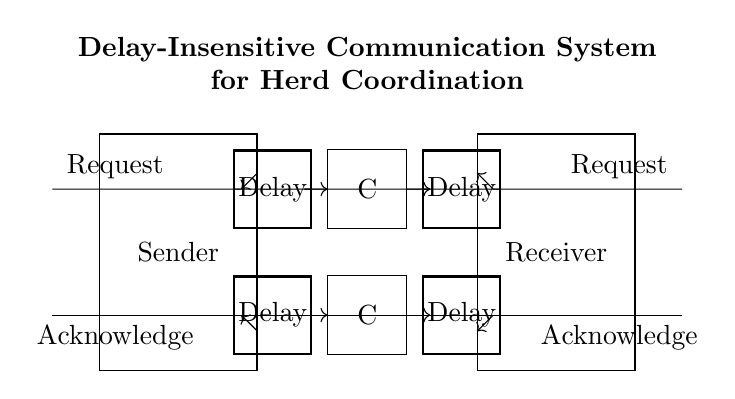What are the main components in this circuit? The main components are a sender, a receiver, and two Muller C-elements, as indicated in the labeled rectangles.
Answer: Sender, Receiver, Muller C-elements How many delay elements are present in the circuit? There are four delay elements, two connected to the top communication line and two connected to the bottom line, as shown in the circuit diagram.
Answer: Four What is the role of the Muller C-elements in this circuit? The Muller C-elements function as synchronization elements that combine the inputs and produce an output only when the inputs are stable, thus facilitating delay-insensitive communication.
Answer: Synchronization What type of communication is this system designed for? The system is designed for asynchronous communication, which is characterized by the operation of components not being tied to a specific timing cycle but instead responding based on signal changes.
Answer: Asynchronous Describe the input and output for the sender. The sender receives requests as inputs and sends out acknowledges as outputs, indicating that it has received a request and is responding to it.
Answer: Request, Acknowledge How does this circuit ensure coordination in a herd? This circuit helps ensure coordination by utilizing communication between multiple nodes (sender and receiver) to maintain stable and synchronized exchanges of information without relying on delays.
Answer: Coordination through communication 